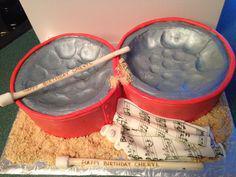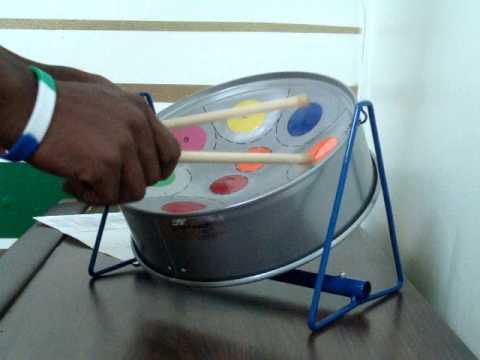The first image is the image on the left, the second image is the image on the right. For the images shown, is this caption "Each image shows a pair of hands holding a pair of drumsticks inside the concave bowl of a silver drum." true? Answer yes or no. No. The first image is the image on the left, the second image is the image on the right. Evaluate the accuracy of this statement regarding the images: "One of these steel drums is not being played by a human right now.". Is it true? Answer yes or no. Yes. 